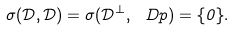Convert formula to latex. <formula><loc_0><loc_0><loc_500><loc_500>\sigma ( \mathcal { D } , \mathcal { D } ) = \sigma ( \mathcal { D } ^ { \perp } , \ D p ) = \{ 0 \} .</formula> 